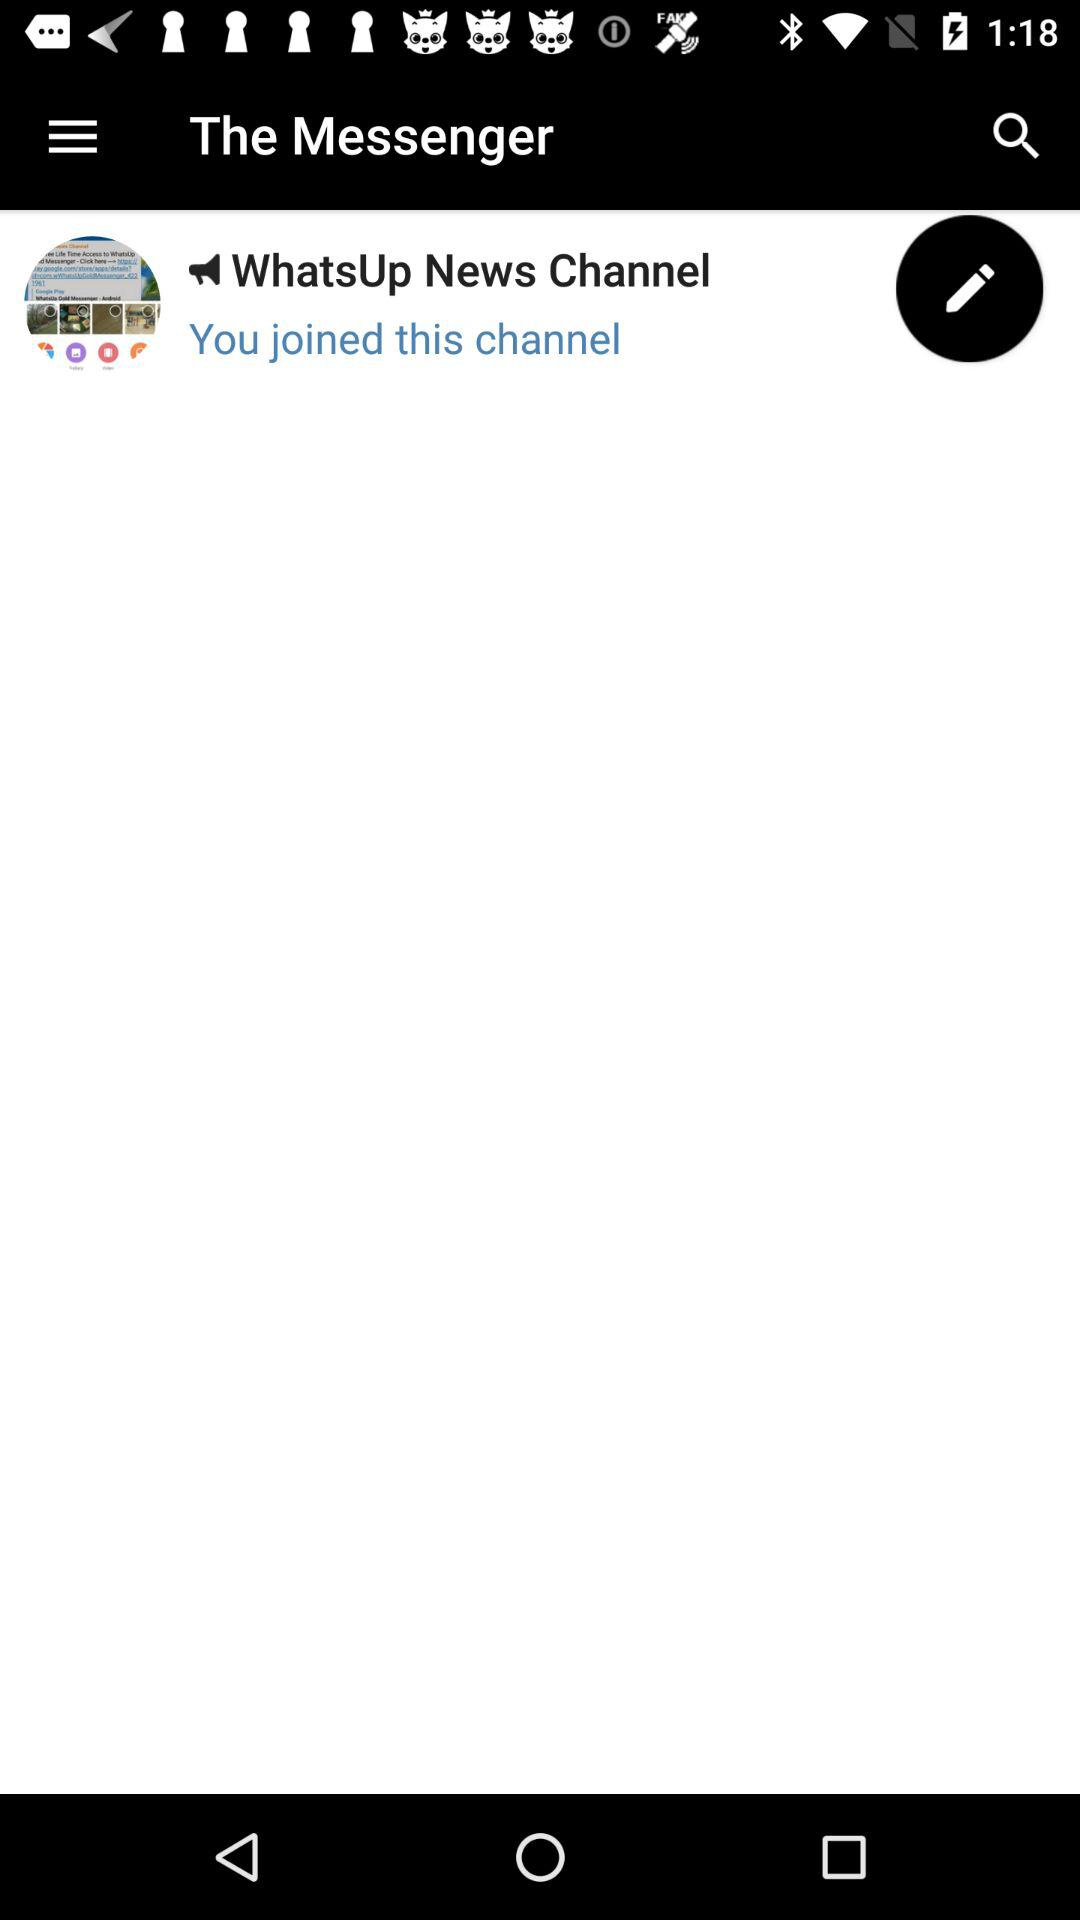What is the channel name? The channel name is "WhatsUp News Channel". 